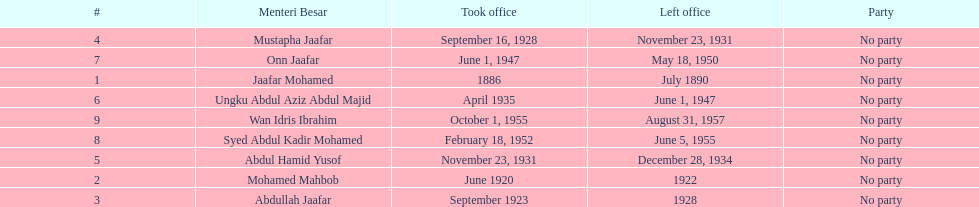What is the number of menteri besars that there have been during the pre-independence period? 9. 